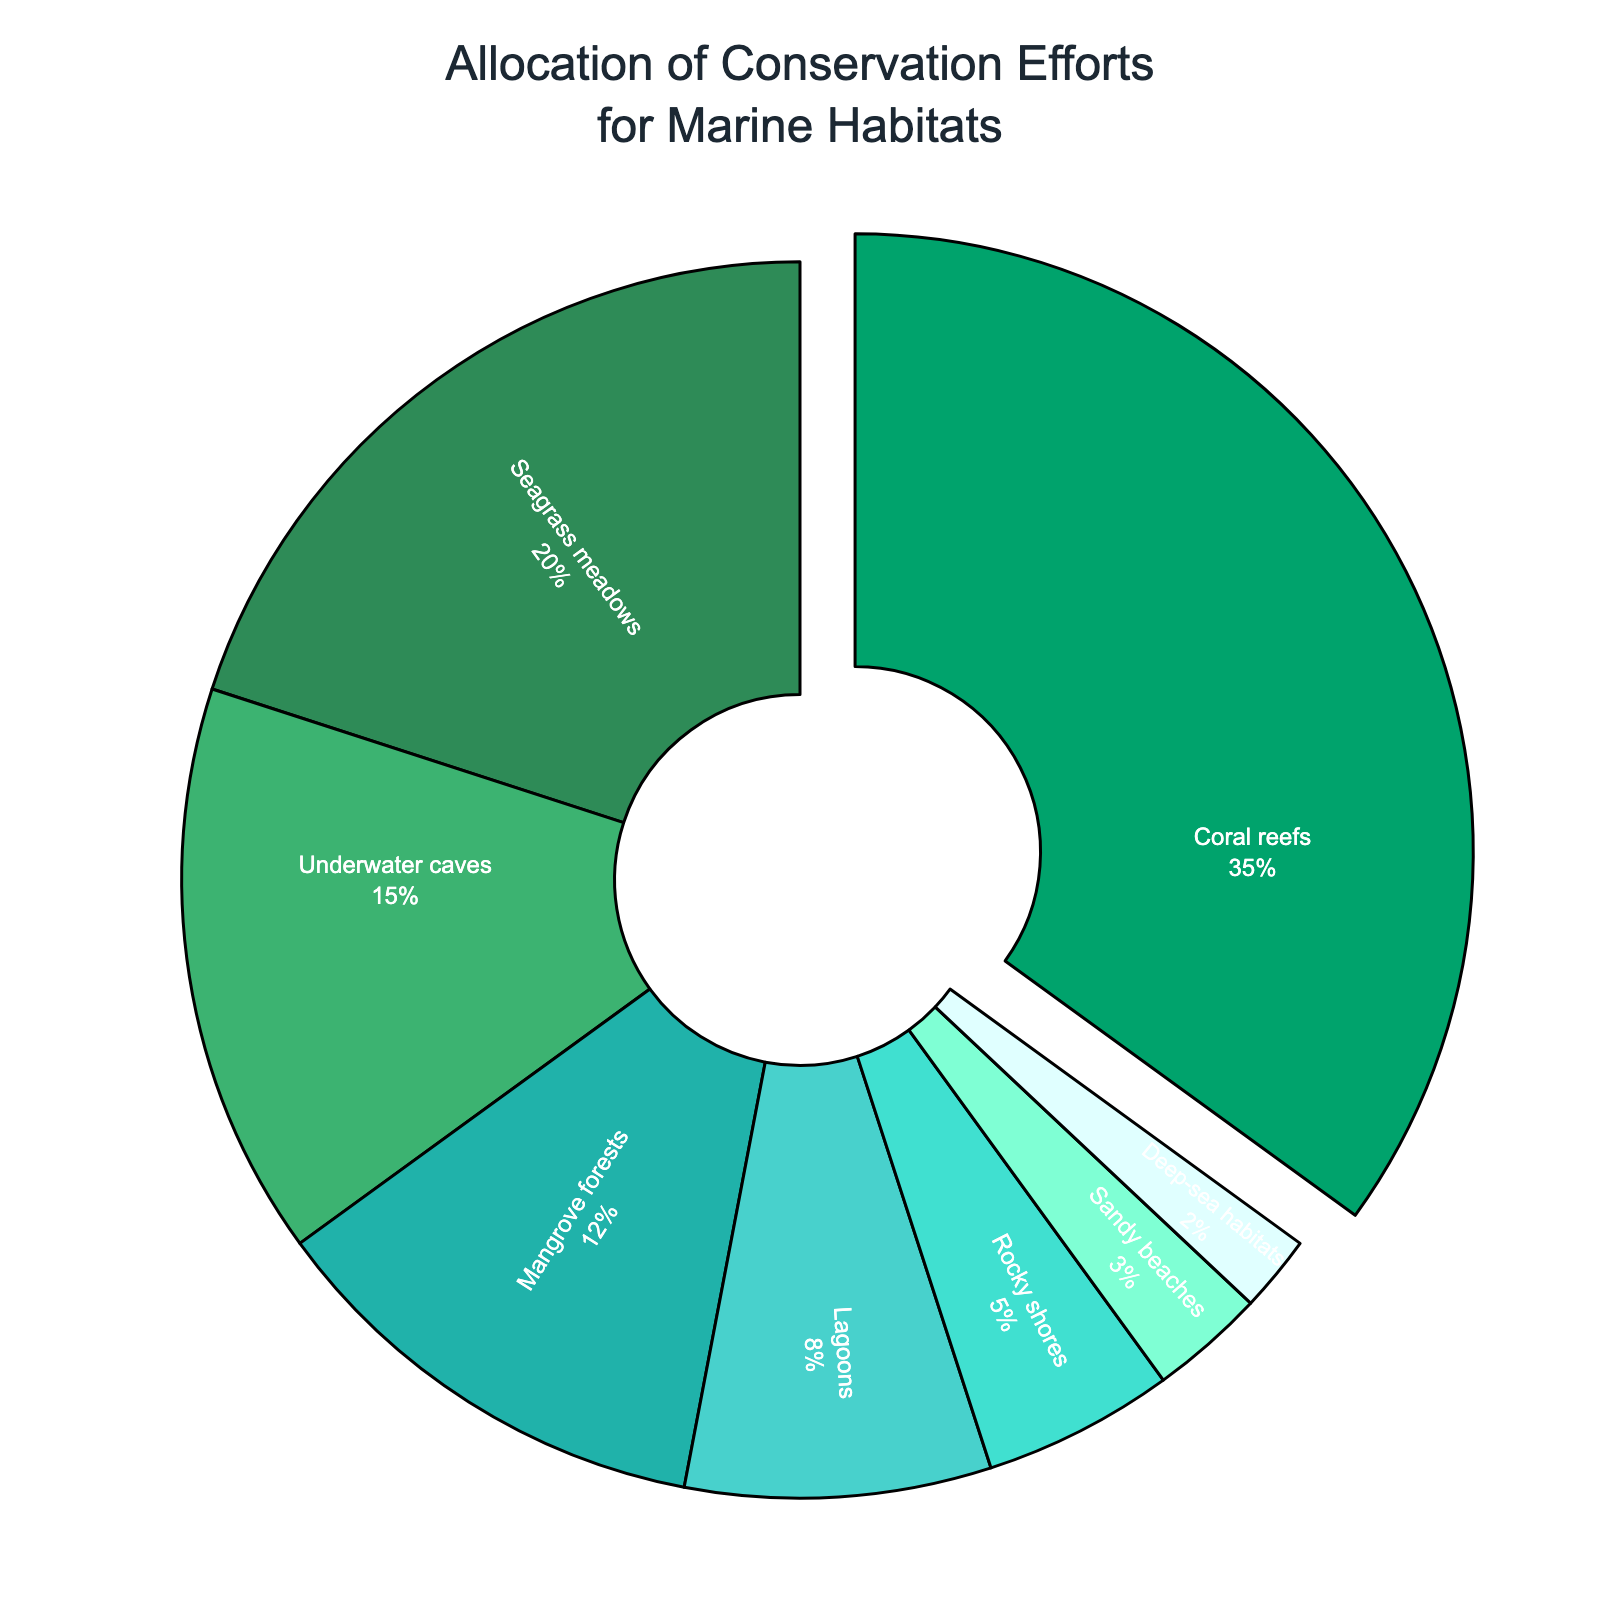What's the habitat receiving the highest allocation of conservation efforts? The habitat with the highest percentage in the pie chart is identified as "Coral reefs," which is visibly the largest section of the chart.
Answer: Coral reefs Which habitat receives less conservation efforts than mangrove forests but more than deep-sea habitats? To determine this, we identify the percentage values for habitats receiving less efforts than mangrove forests (12%) and more than deep-sea habitats (2%). By inspecting the pie chart, "Lagoons" (8%) fits this condition.
Answer: Lagoons What is the combined percentage of seagrass meadows and mangrove forests? Summing the percentages of seagrass meadows (20%) and mangrove forests (12%) gives a total allocation of 20 + 12 = 32.
Answer: 32 Are there any habitats that receive the same allocation percentage? By examining the percentages in the pie chart, none of the habitats have identical allocations. Each habitat is represented by a unique percentage.
Answer: No What is the difference in allocation between underwater caves and sandy beaches? The allocation for underwater caves is 15% and for sandy beaches it is 3%. The difference is calculated as 15 - 3 = 12.
Answer: 12 Which two habitats have a combined conservation effort allocation equal to the effort allocated for coral reefs? Coral reefs have 35% allocation. Looking at combinations, we find that seagrass meadows (20%) and underwater caves (15%) together sum up to 20 + 15 = 35.
Answer: Seagrass meadows and underwater caves What is the total percentage of conservation efforts allocated to underwater caves, lagoons, and rocky shores? Summing the percentages of underwater caves (15%), lagoons (8%), and rocky shores (5%) gives a total of 15 + 8 + 5 = 28.
Answer: 28 Which habitat's section has a green color and what percentage does it represent? The section with the green color, darker shade, represents "Coral reefs," which has a 35% allocation.
Answer: Coral reefs, 35 How many habitats receive a lesser conservation effort than seagrass meadows? Seagrass meadows have a 20% allocation. By counting the segments with lesser percentages, we identify six habitats: underwater caves, mangrove forests, lagoons, rocky shores, sandy beaches, and deep-sea habitats.
Answer: 6 What is the allocation for the habitat with the smallest effort and which habitat is it? The smallest section of the pie chart represents "Deep-sea habitats," which has an allocation of 2%.
Answer: Deep-sea habitats, 2 